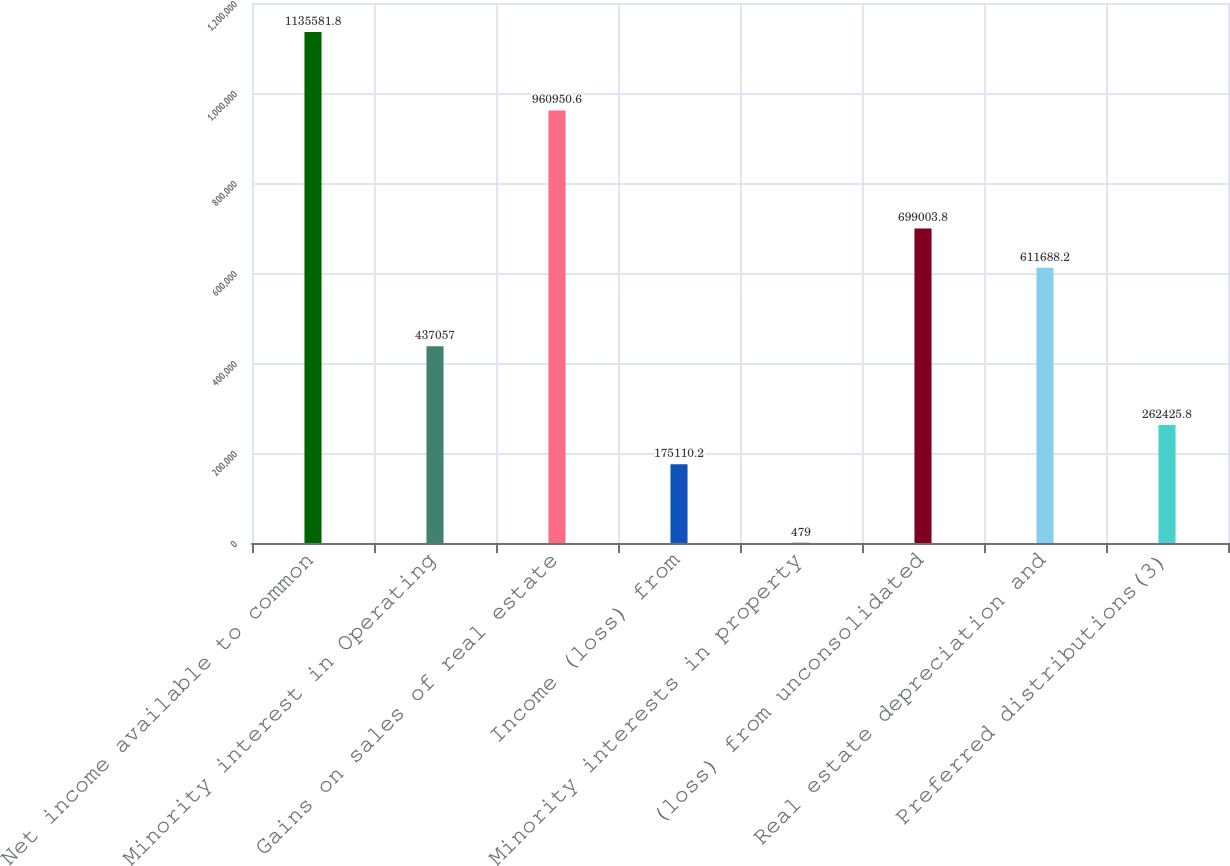<chart> <loc_0><loc_0><loc_500><loc_500><bar_chart><fcel>Net income available to common<fcel>Minority interest in Operating<fcel>Gains on sales of real estate<fcel>Income (loss) from<fcel>Minority interests in property<fcel>(loss) from unconsolidated<fcel>Real estate depreciation and<fcel>Preferred distributions(3)<nl><fcel>1.13558e+06<fcel>437057<fcel>960951<fcel>175110<fcel>479<fcel>699004<fcel>611688<fcel>262426<nl></chart> 